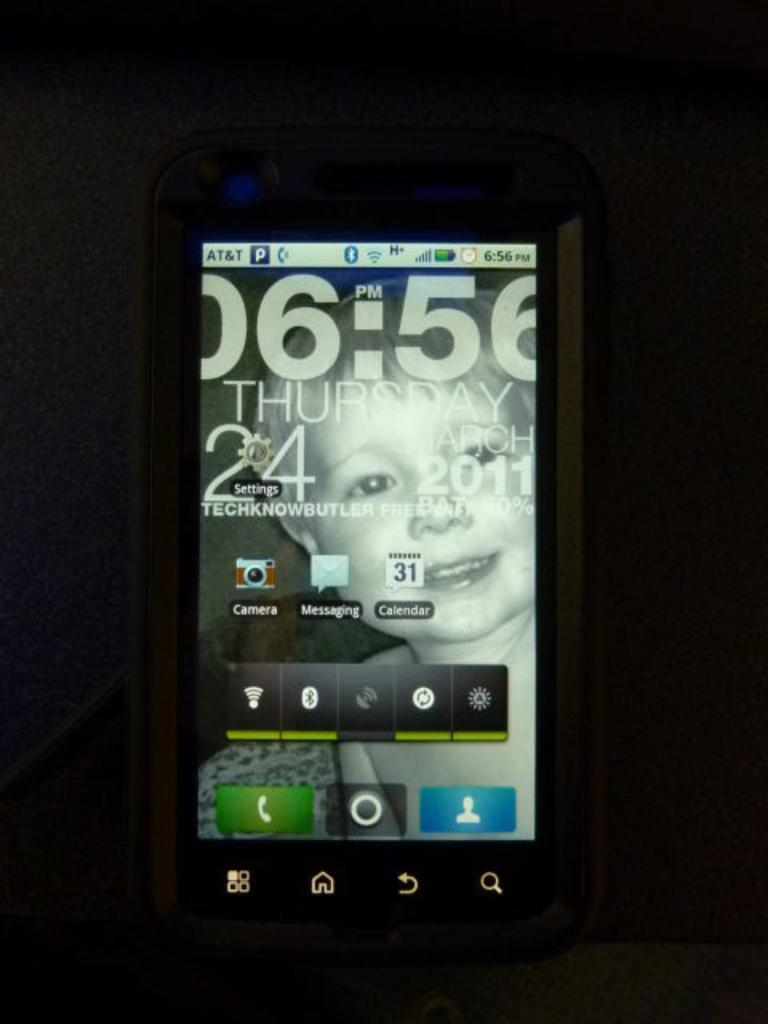What is the main subject in the center of the image? There is a mobile in the center of the image. What type of account is required to access the coast in the image? There is no mention of an account or a coast in the image; it only features a mobile. 